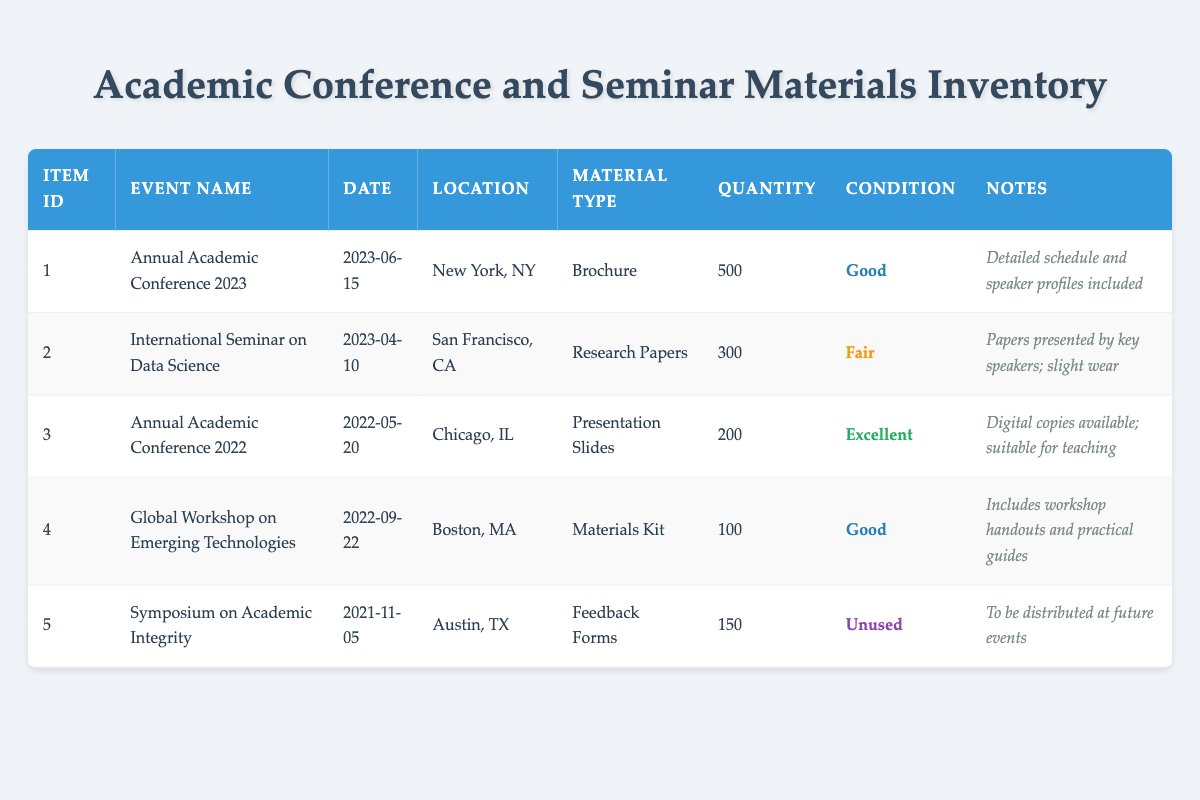What is the total quantity of materials from the Annual Academic Conference 2023? From the table, the Annual Academic Conference 2023 has a quantity of 500 brochures. Therefore, the total quantity of materials from this event is simply 500.
Answer: 500 Which event has the most materials available? By comparing the quantities listed in the table, the Annual Academic Conference 2023 has 500 brochures, which is more than any other event's materials. The next highest quantity is 300 from the International Seminar on Data Science. Thus, the event with the most materials available is the Annual Academic Conference 2023.
Answer: Annual Academic Conference 2023 Is there any unused material in the inventory? The table shows that the Symposium on Academic Integrity has 150 unused feedback forms listed under the condition "Unused." Therefore, yes, there is unused material in the inventory.
Answer: Yes What is the quantity difference between the materials from the Annual Academic Conference 2022 and the Symposium on Academic Integrity? The Annual Academic Conference 2022 has 200 presentation slides while the Symposium on Academic Integrity has 150 feedback forms. To find the difference, subtract 150 from 200, which equals 50.
Answer: 50 Are there any materials in excellent condition? Checking the conditions listed in the table, the Annual Academic Conference 2022 has presentation slides marked as "Excellent." This indicates there are materials in excellent condition.
Answer: Yes Which location hosted the International Seminar on Data Science? Referring to the table, the International Seminar on Data Science took place in San Francisco, CA. Thus, that is the location mentioned.
Answer: San Francisco, CA What is the average quantity of materials per event? The total quantity of materials across all events is 500 + 300 + 200 + 100 + 150 = 1350. There are 5 events listed. To find the average, divide the total quantity (1350) by the number of events (5), which gives 270.
Answer: 270 How many materials are in good condition? From the table, the Annual Academic Conference 2023 and the Global Workshop on Emerging Technologies are in good condition, with quantities of 500 and 100, respectively. Adding these gives a total of 600 materials in good condition.
Answer: 600 What types of materials were provided at the Global Workshop on Emerging Technologies? The table shows that the Global Workshop on Emerging Technologies provided a "Materials Kit." Therefore, that is the type of material provided at this workshop.
Answer: Materials Kit 